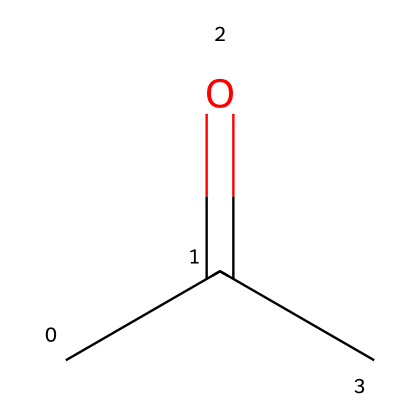How many carbon atoms are in acetone? The SMILES representation "CC(=O)C" indicates the presence of three carbon atoms: two in the "CC" part and one in the final "C" after the carbonyl group.
Answer: 3 What functional group is present in acetone? In the given SMILES, the "=O" indicates the presence of a carbonyl group (C=O), which is characteristic of ketones, including acetone.
Answer: carbonyl group What are the types of bonds present in acetone? The SMILES "CC(=O)C" shows single bonds between the carbon atoms and a double bond between one carbon and oxygen (the carbonyl), indicating both single and double bonds are present.
Answer: single and double bonds What is the molecular formula of acetone? From the interpretation of the SMILES structure, acetone consists of three carbon atoms, six hydrogen atoms, and one oxygen atom, leading to the molecular formula C3H6O.
Answer: C3H6O Is acetone a polar or nonpolar molecule? The presence of the polar carbonyl group impacts polarity; although the molecule has nonpolar C-H bonds, the overall structure results in a polar molecule.
Answer: polar How does the structure of acetone affect its volatility? The molecular structure of acetone, with small size and polar functional group, allows for relatively weak intermolecular forces (dipole-dipole interactions and London dispersion forces), contributing to higher volatility.
Answer: higher volatility 